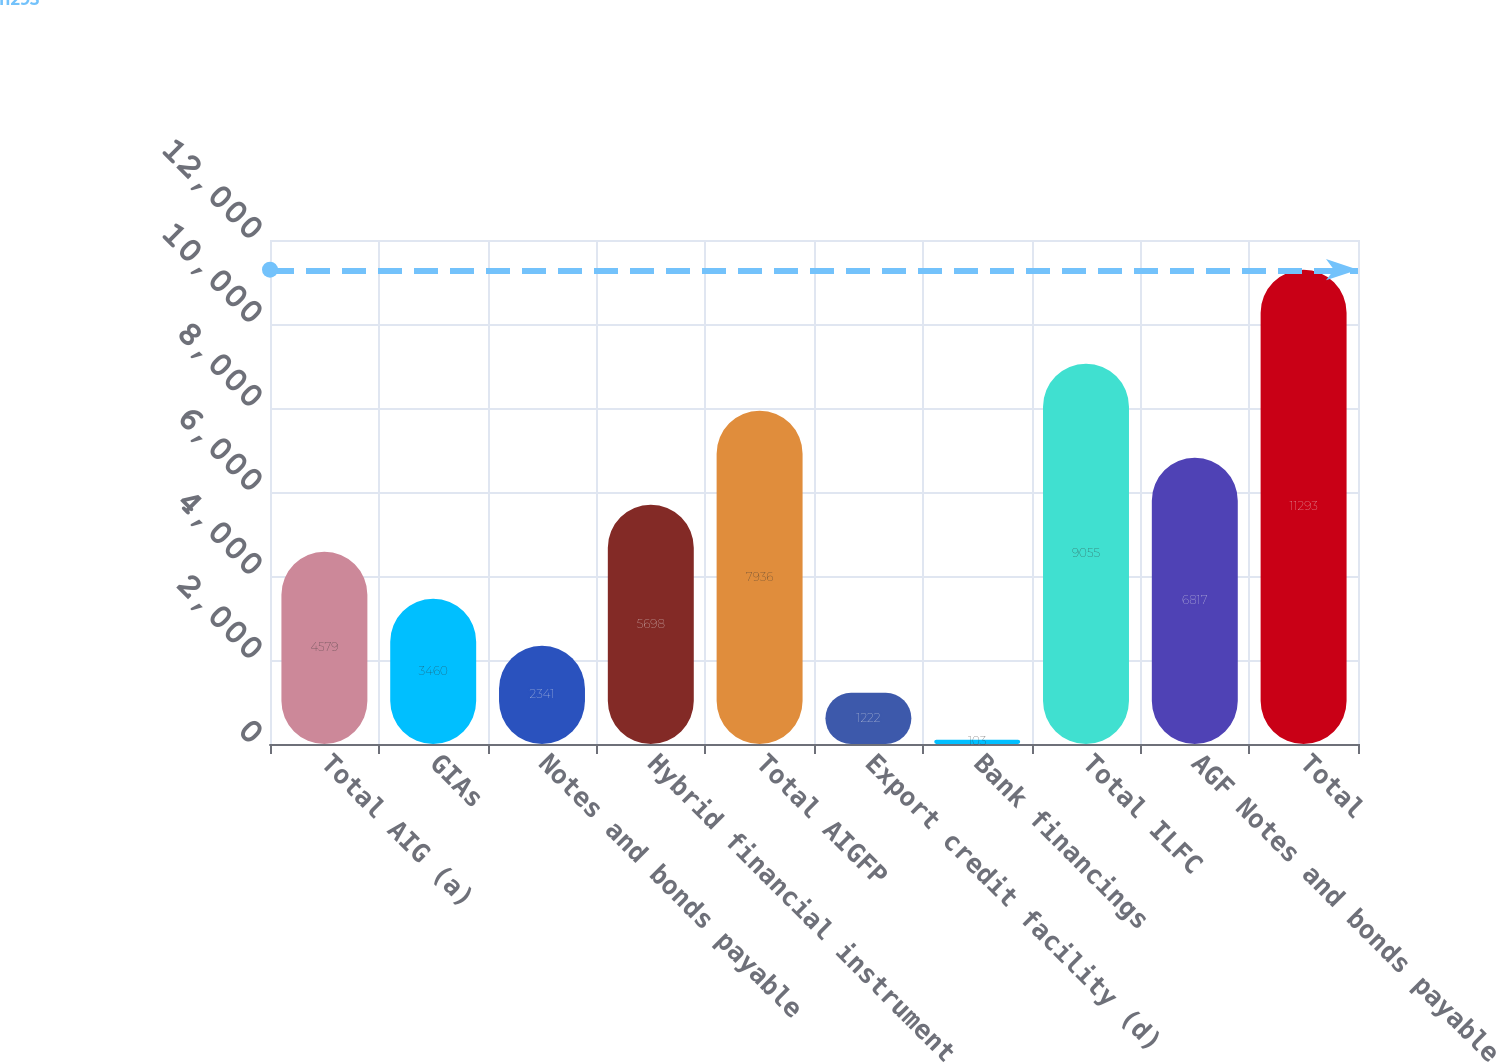<chart> <loc_0><loc_0><loc_500><loc_500><bar_chart><fcel>Total AIG (a)<fcel>GIAs<fcel>Notes and bonds payable<fcel>Hybrid financial instrument<fcel>Total AIGFP<fcel>Export credit facility (d)<fcel>Bank financings<fcel>Total ILFC<fcel>AGF Notes and bonds payable<fcel>Total<nl><fcel>4579<fcel>3460<fcel>2341<fcel>5698<fcel>7936<fcel>1222<fcel>103<fcel>9055<fcel>6817<fcel>11293<nl></chart> 